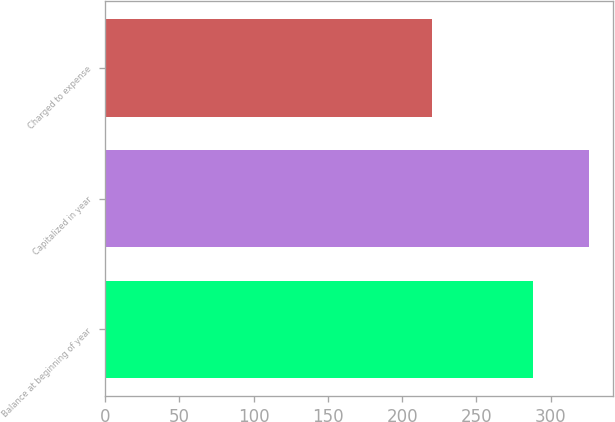Convert chart to OTSL. <chart><loc_0><loc_0><loc_500><loc_500><bar_chart><fcel>Balance at beginning of year<fcel>Capitalized in year<fcel>Charged to expense<nl><fcel>288<fcel>326<fcel>220<nl></chart> 